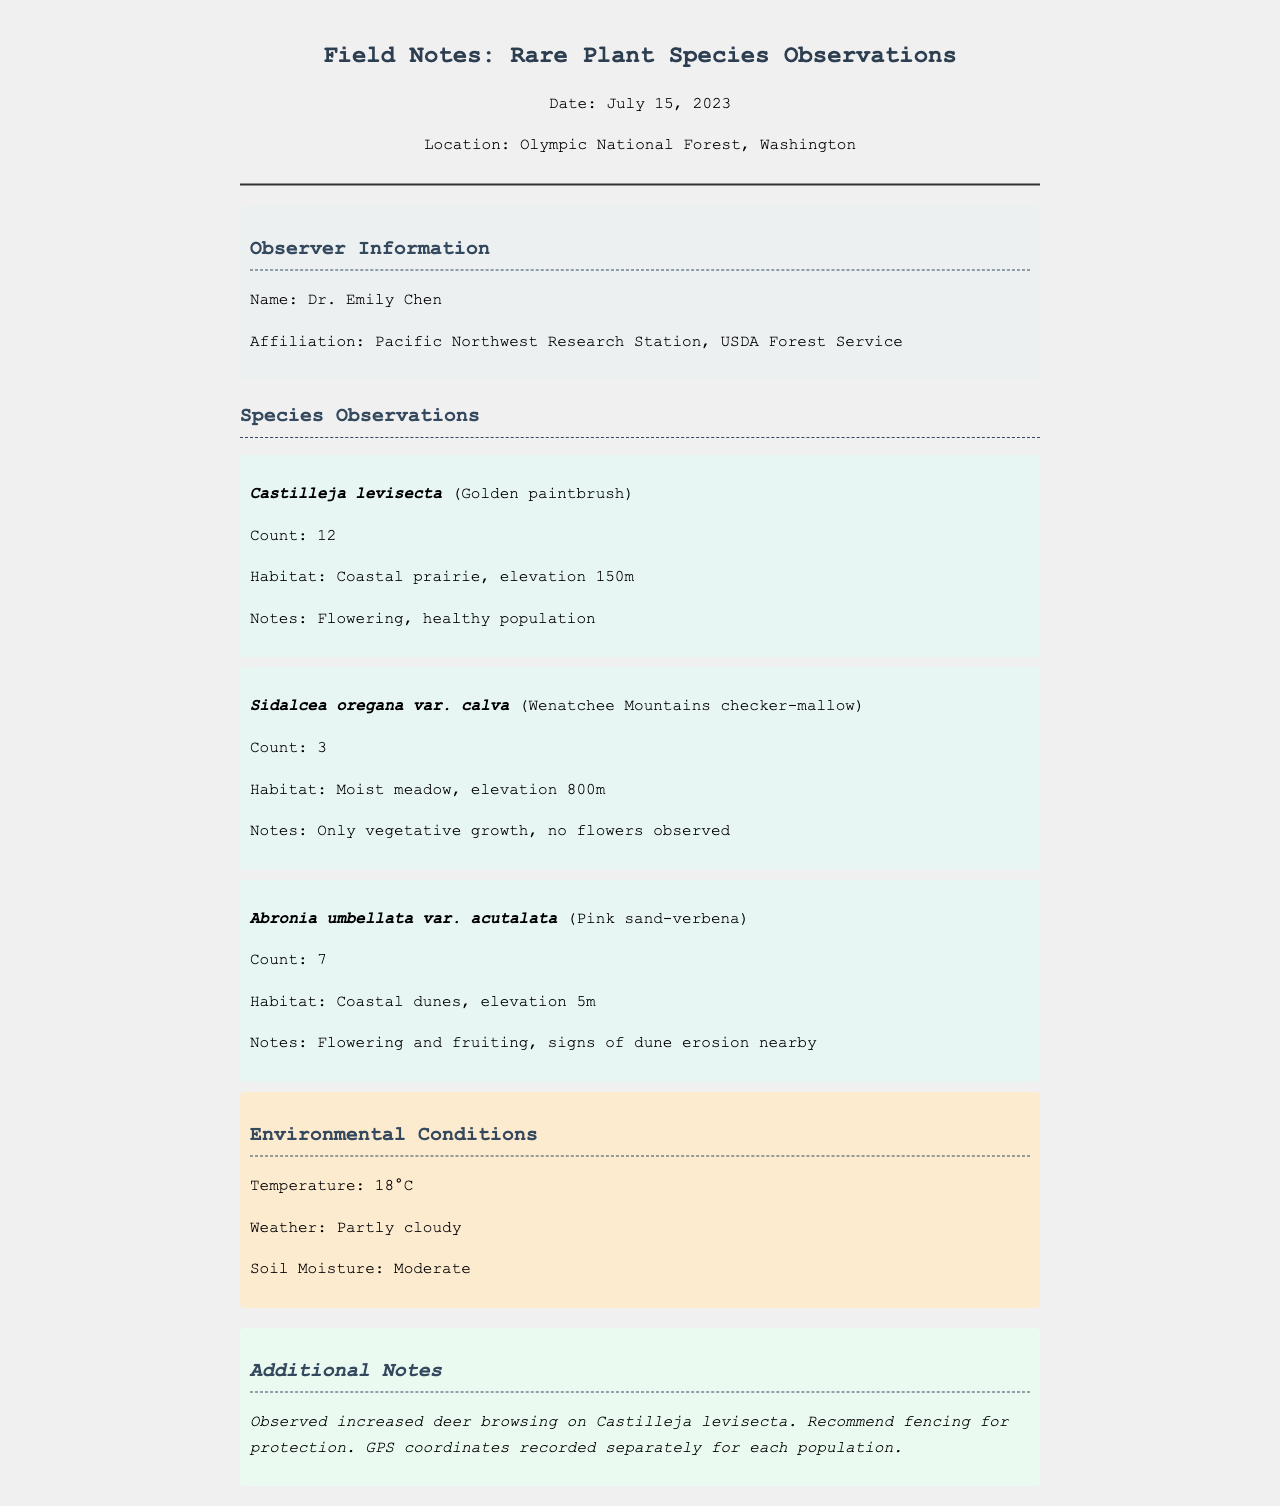What is the date of the observations? The date of the observations is explicitly stated in the header of the document.
Answer: July 15, 2023 Who is the observer of the field notes? The observer's name is provided in the observer information section of the document.
Answer: Dr. Emily Chen How many individuals of Castilleja levisecta were observed? The count for Castilleja levisecta is listed under its observation details.
Answer: 12 What elevation was the habitat of Sidalcea oregana var. calva? The elevation for the habitat is specified in the observation details for that species.
Answer: 800m What is one environmental condition noted in the document? The environmental conditions section lists specific data regarding the weather, temperature, and soil moisture.
Answer: Moderate (soil moisture) What recommendation is made regarding Castilleja levisecta? The additional notes section describes a recommendation based on observed conditions.
Answer: Fencing for protection How many species were documented in total? The number of species can be determined by counting the distinct species observations presented in the document.
Answer: 3 What habitat type is associated with Abronia umbellata var. acutalata? The habitat type for Abronia umbellata var. acutalata is included in the observation details.
Answer: Coastal dunes What keyword indicates the health status of the Castilleja levisecta population? The observation notes for Castilleja levisecta state the condition of the population.
Answer: Healthy 